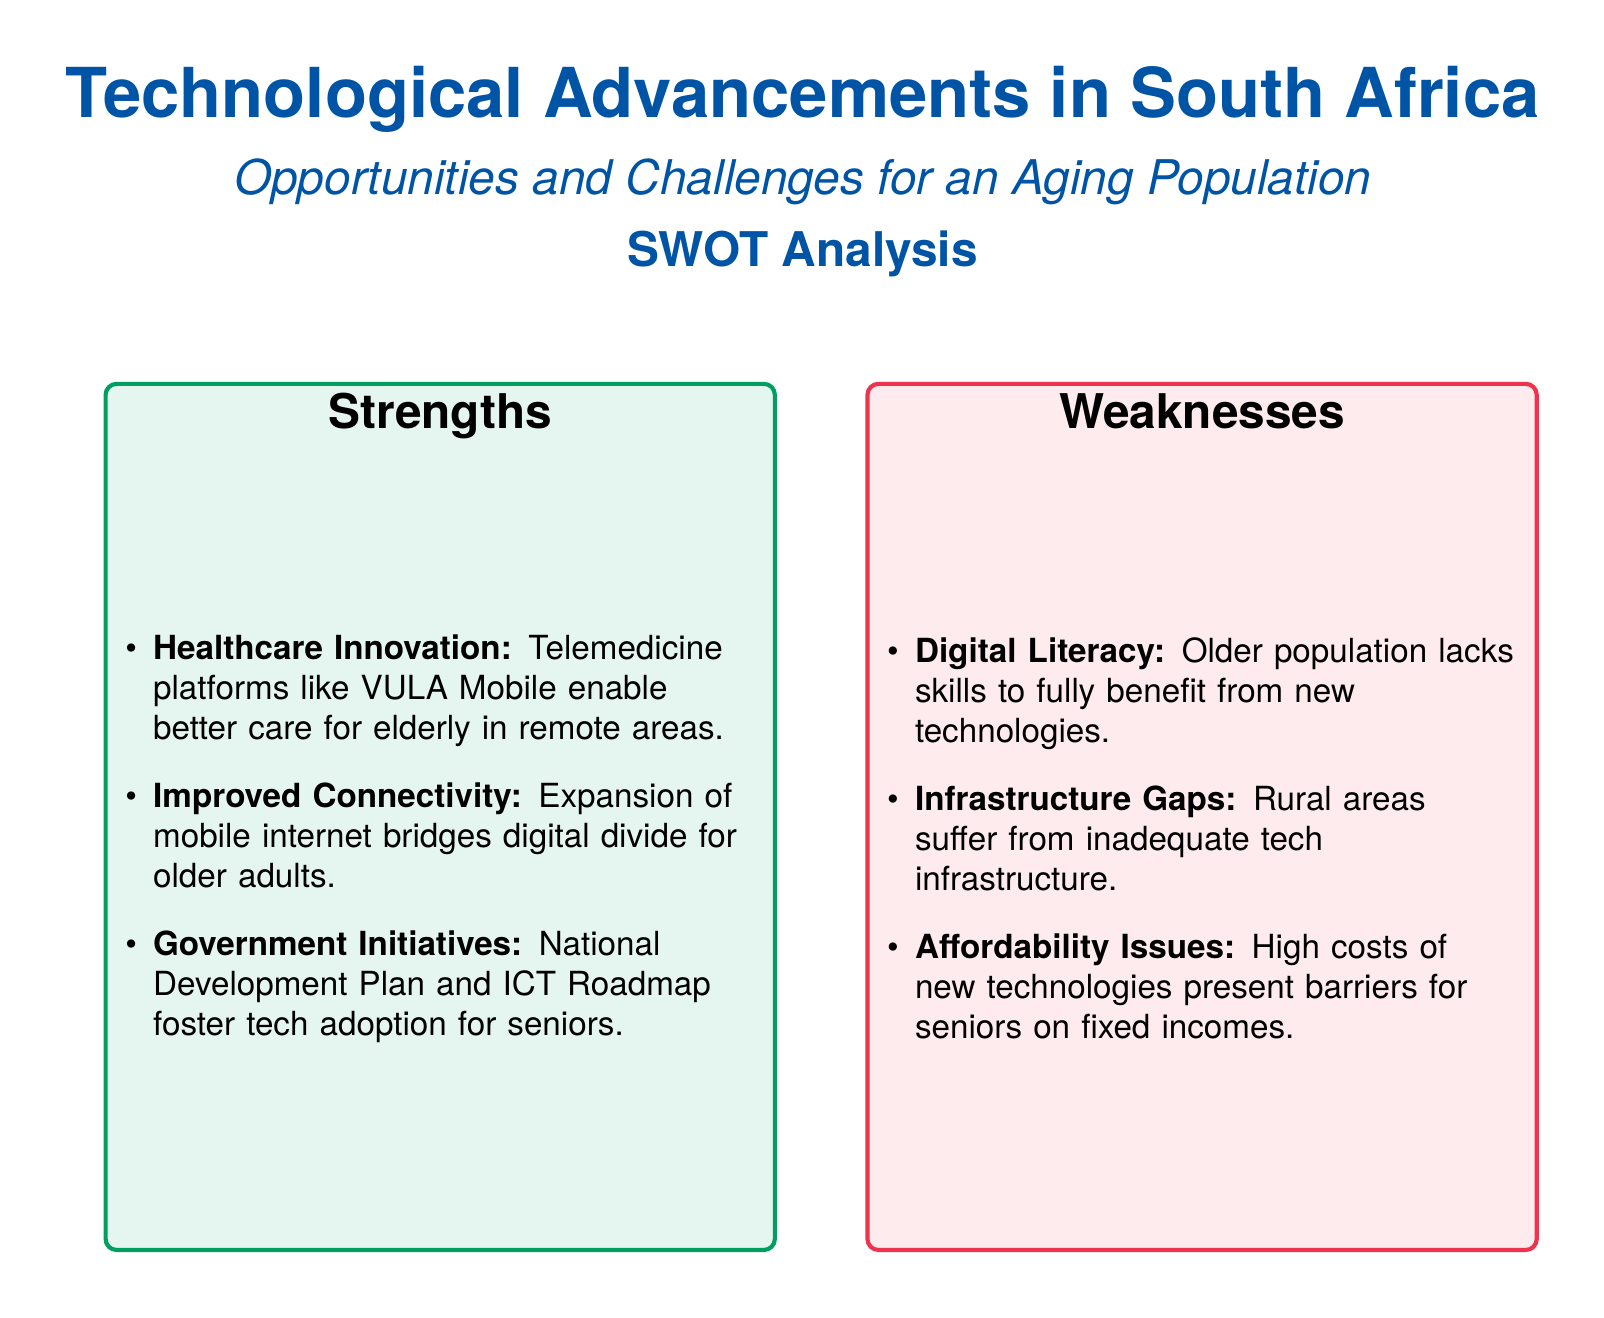what is the title of the document? The title of the document is displayed at the top of the rendered view, which is "Technological Advancements in South Africa".
Answer: Technological Advancements in South Africa what color represents strengths? The strengths section is represented by a green color indicated in the document.
Answer: green which telemedicine platform is mentioned for elderly care? The document lists one specific telemedicine platform that aids elderly care, which is "VULA Mobile".
Answer: VULA Mobile what type of risks are older adults vulnerable to according to the threats? The document lists a specific risk older adults face as mentioned in the threats section, which is "Cybersecurity Risks".
Answer: Cybersecurity Risks what does the SWOT analysis include? The SWOT analysis includes four distinct sections that analyze strengths, weaknesses, opportunities, and threats.
Answer: strengths, weaknesses, opportunities, threats which specific problem related to technology does the document highlight for older adults? One specific problem highlighted in the weaknesses section is the issue of "Digital Literacy".
Answer: Digital Literacy what initiative aims to improve tech adoption for seniors according to the document? The document mentions "National Development Plan" as an initiative to improve tech adoption for seniors.
Answer: National Development Plan what type of partnerships does the opportunities section suggest could be beneficial? The document suggests "Public-Private Partnerships" as a beneficial strategic approach in the opportunities section.
Answer: Public-Private Partnerships how many weaknesses are identified in the document? The document lists three specific weaknesses related to technological advancements for the aging population.
Answer: three 